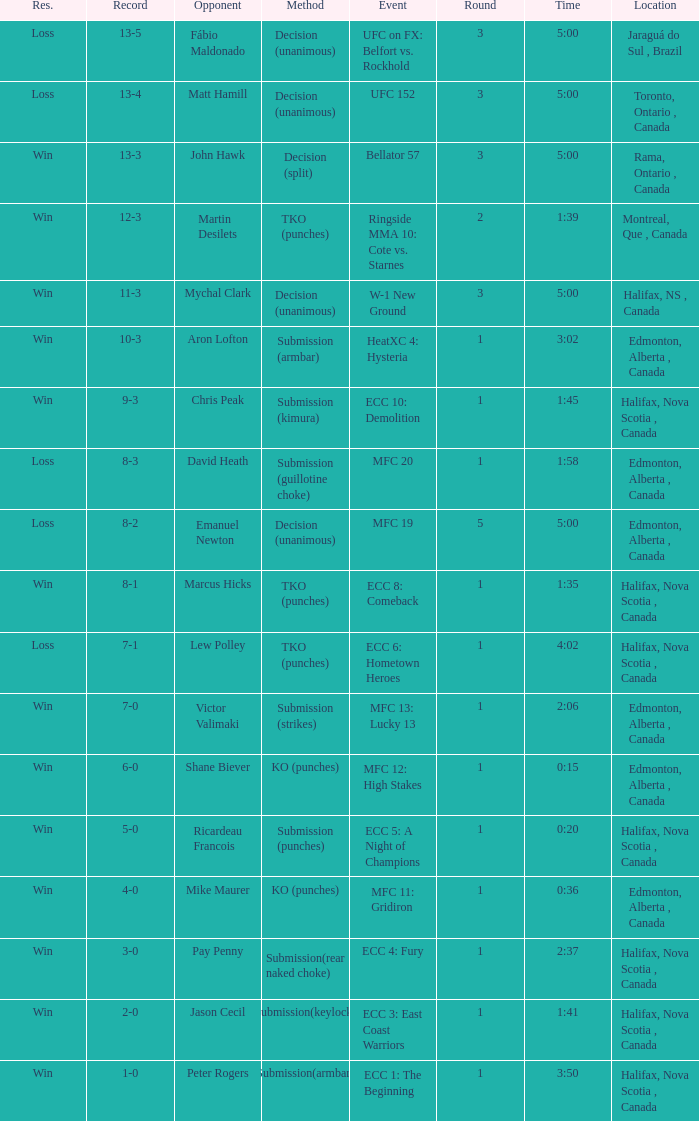In which venue is the match being held where aron lofton is the opponent? Edmonton, Alberta , Canada. 